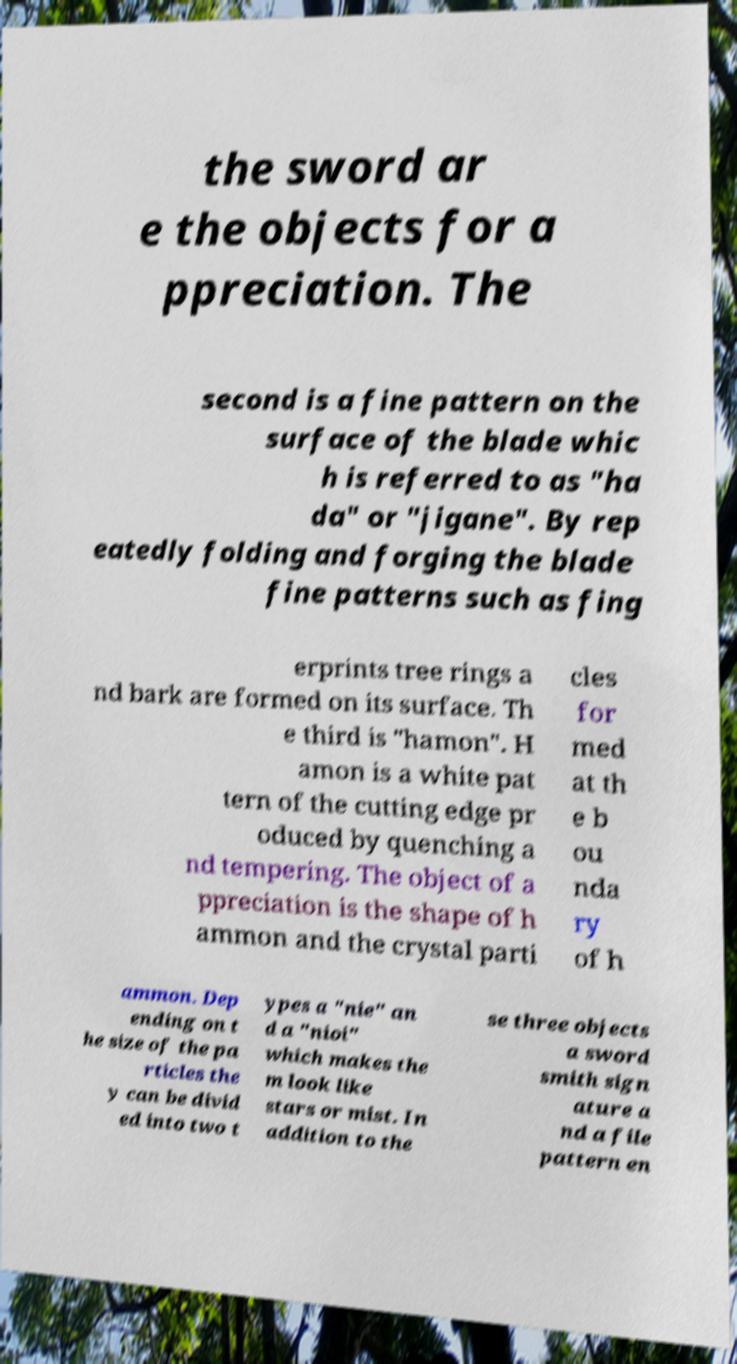What messages or text are displayed in this image? I need them in a readable, typed format. the sword ar e the objects for a ppreciation. The second is a fine pattern on the surface of the blade whic h is referred to as "ha da" or "jigane". By rep eatedly folding and forging the blade fine patterns such as fing erprints tree rings a nd bark are formed on its surface. Th e third is "hamon". H amon is a white pat tern of the cutting edge pr oduced by quenching a nd tempering. The object of a ppreciation is the shape of h ammon and the crystal parti cles for med at th e b ou nda ry of h ammon. Dep ending on t he size of the pa rticles the y can be divid ed into two t ypes a "nie" an d a "nioi" which makes the m look like stars or mist. In addition to the se three objects a sword smith sign ature a nd a file pattern en 